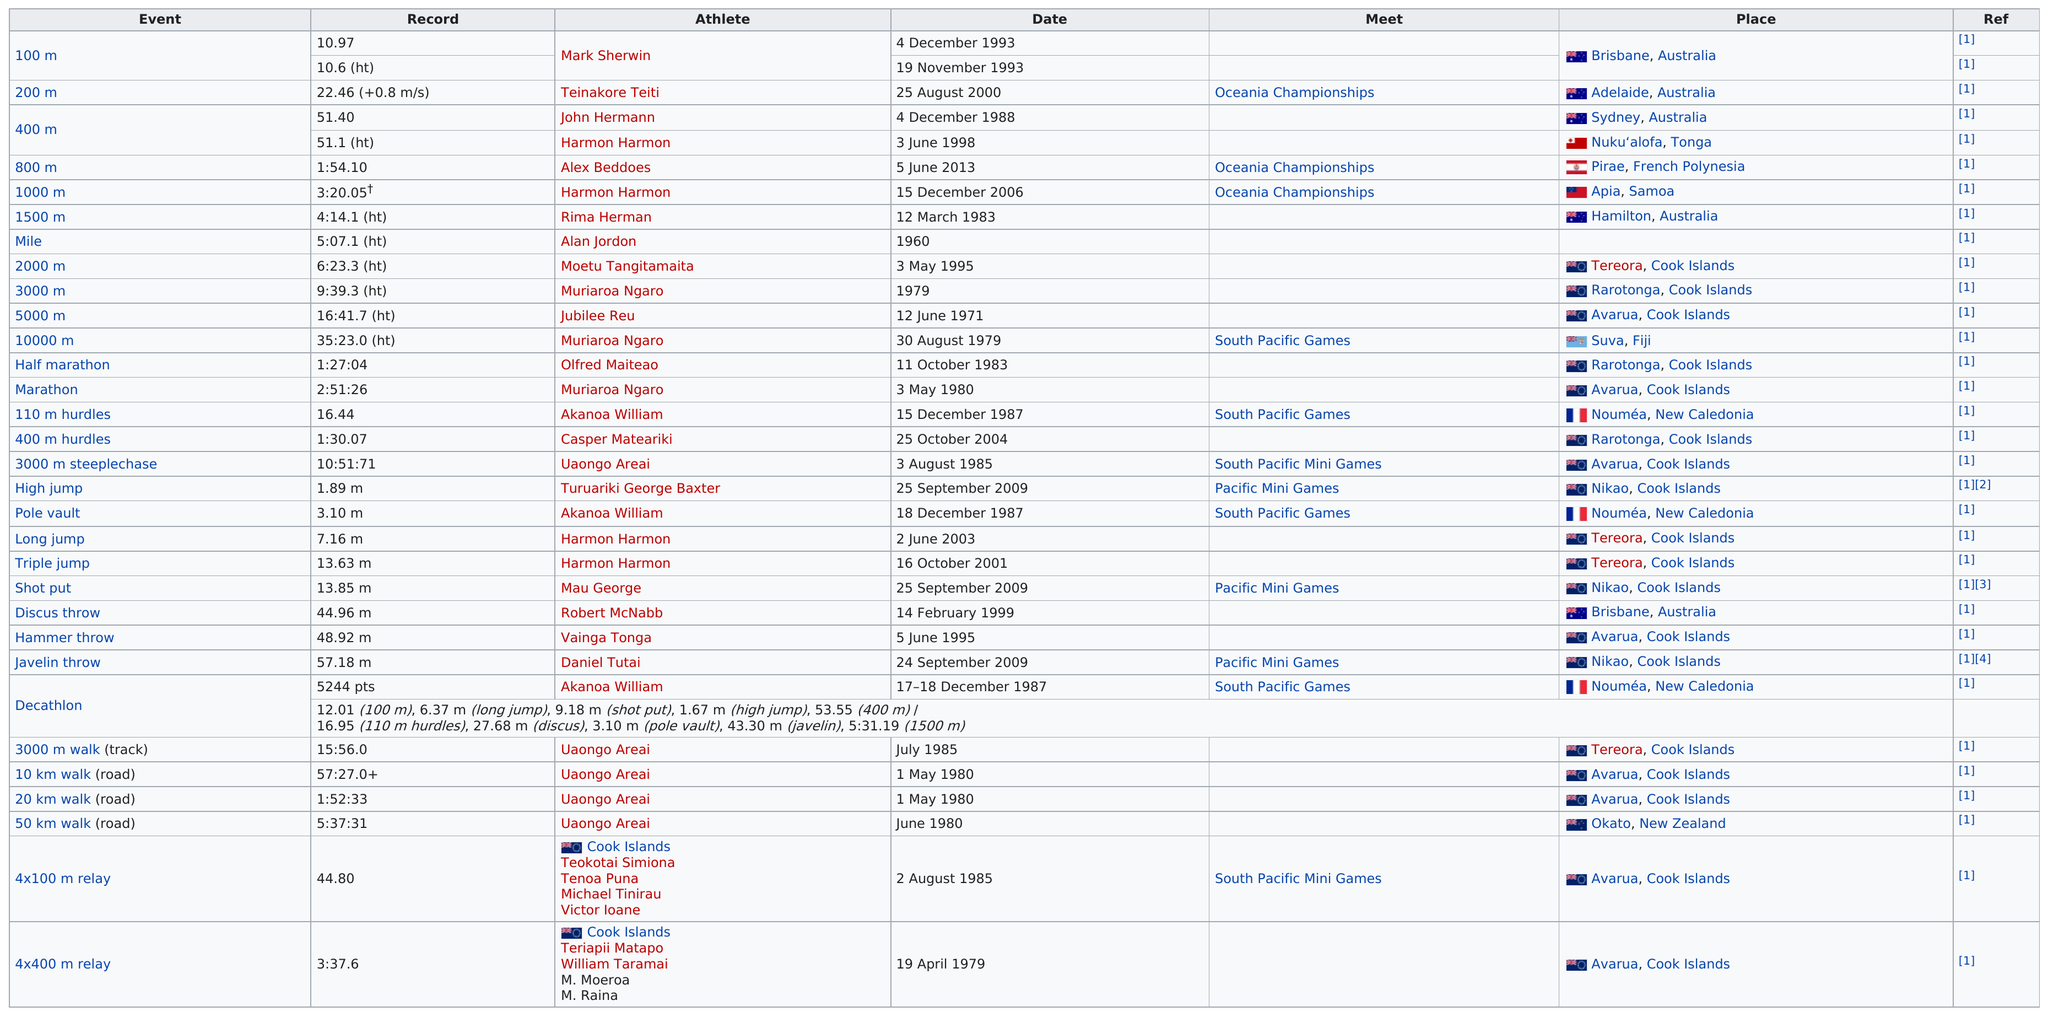Specify some key components in this picture. Who holds the top record in the 110 m hurdles? It is Akanoa William. The record for the 400 meters was set earlier than the record for the 200 meters. The chart lists Brisbane, Australia as the top place. On which date does 15 December 2006 come before 12 March 1983? After the 400-meter event, the 800-meter event will take place. 